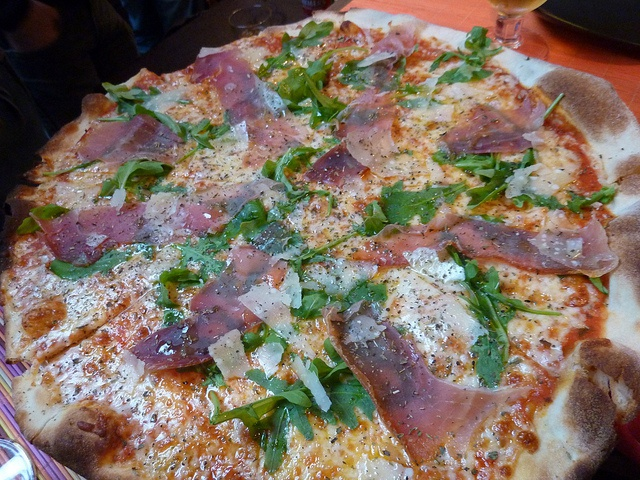Describe the objects in this image and their specific colors. I can see pizza in darkgray, black, gray, and tan tones and wine glass in black, brown, and tan tones in this image. 